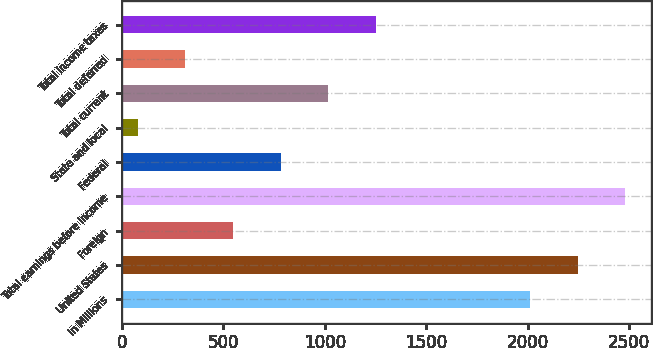Convert chart. <chart><loc_0><loc_0><loc_500><loc_500><bar_chart><fcel>In Millions<fcel>United States<fcel>Foreign<fcel>Total earnings before income<fcel>Federal<fcel>State and local<fcel>Total current<fcel>Total deferred<fcel>Total income taxes<nl><fcel>2011<fcel>2246.13<fcel>547.16<fcel>2481.26<fcel>782.29<fcel>76.9<fcel>1017.42<fcel>312.03<fcel>1252.55<nl></chart> 